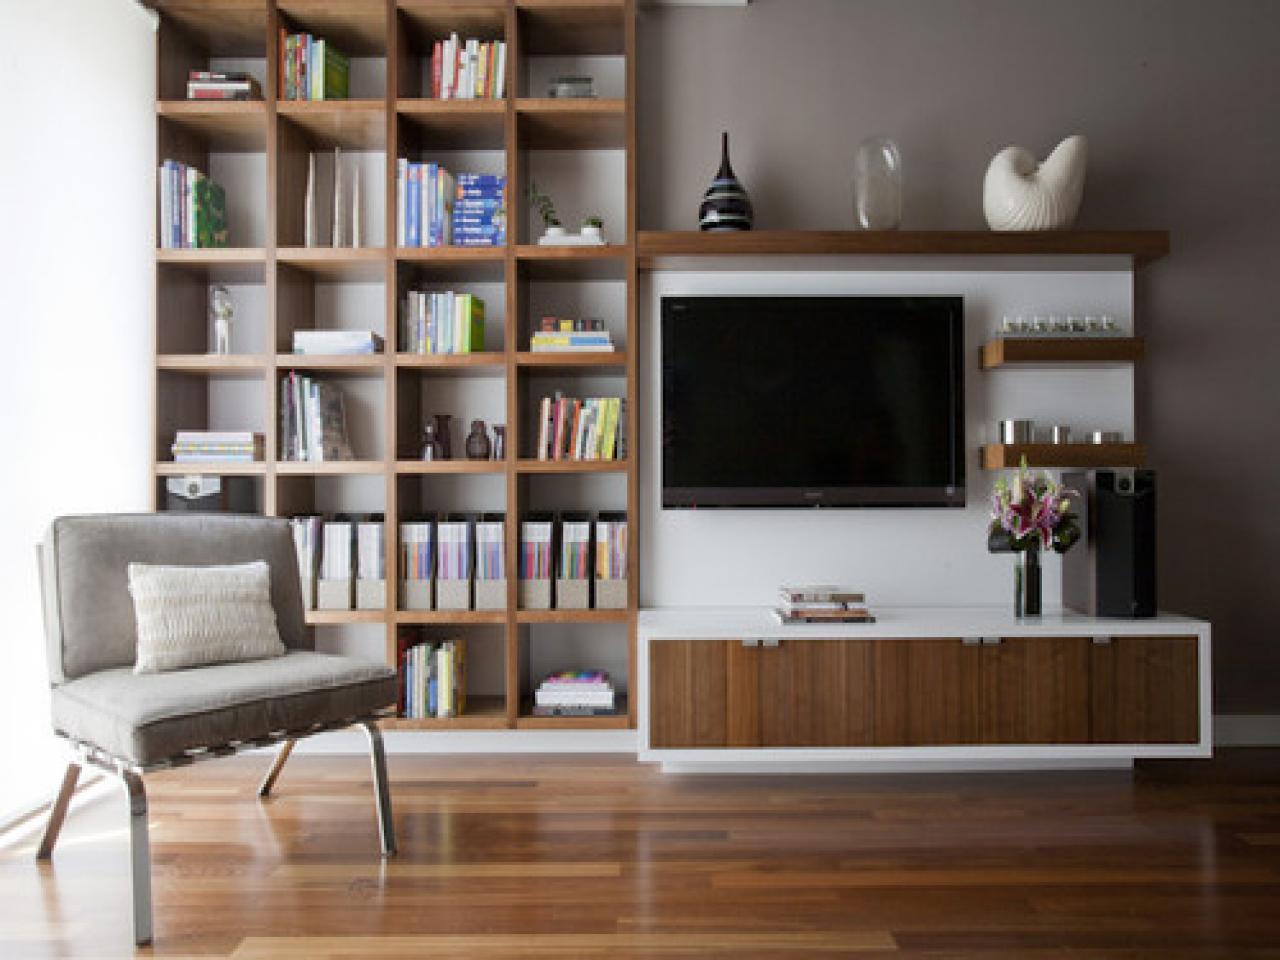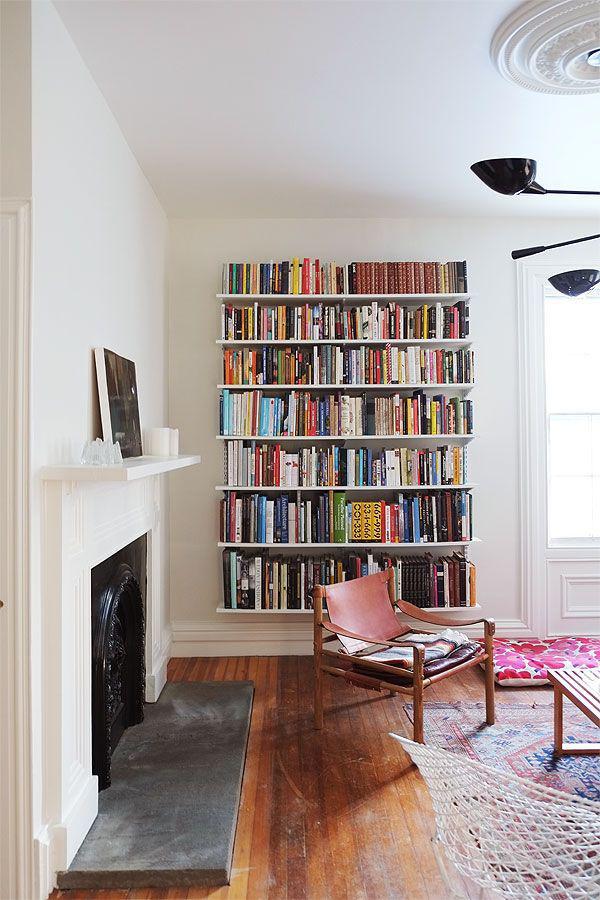The first image is the image on the left, the second image is the image on the right. Considering the images on both sides, is "In the left image there is a ladder leaning against the bookcase." valid? Answer yes or no. No. The first image is the image on the left, the second image is the image on the right. Considering the images on both sides, is "One image includes a ladder leaning on a wall of bookshelves in a room with a wood floor and a pale rug." valid? Answer yes or no. No. 